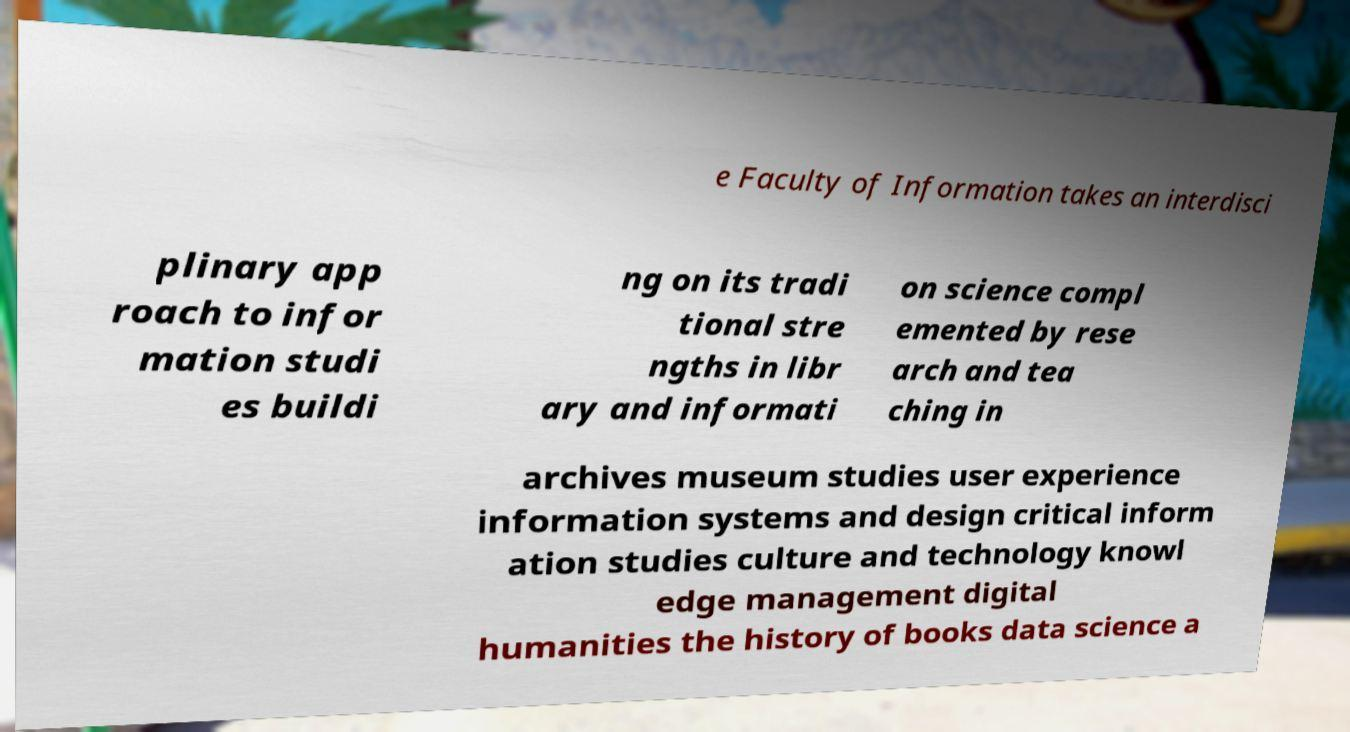Could you assist in decoding the text presented in this image and type it out clearly? e Faculty of Information takes an interdisci plinary app roach to infor mation studi es buildi ng on its tradi tional stre ngths in libr ary and informati on science compl emented by rese arch and tea ching in archives museum studies user experience information systems and design critical inform ation studies culture and technology knowl edge management digital humanities the history of books data science a 